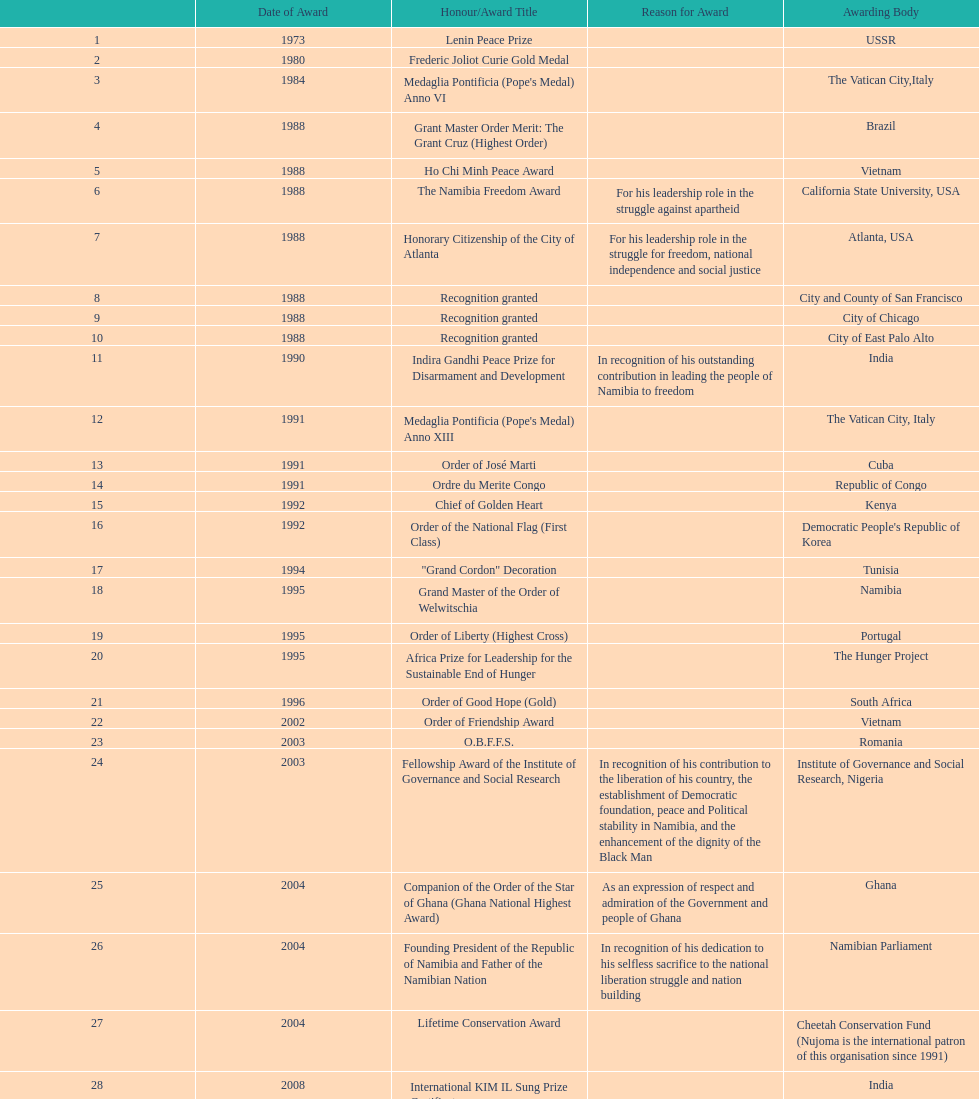What is the cumulative number of awards won by nujoma? 29. 